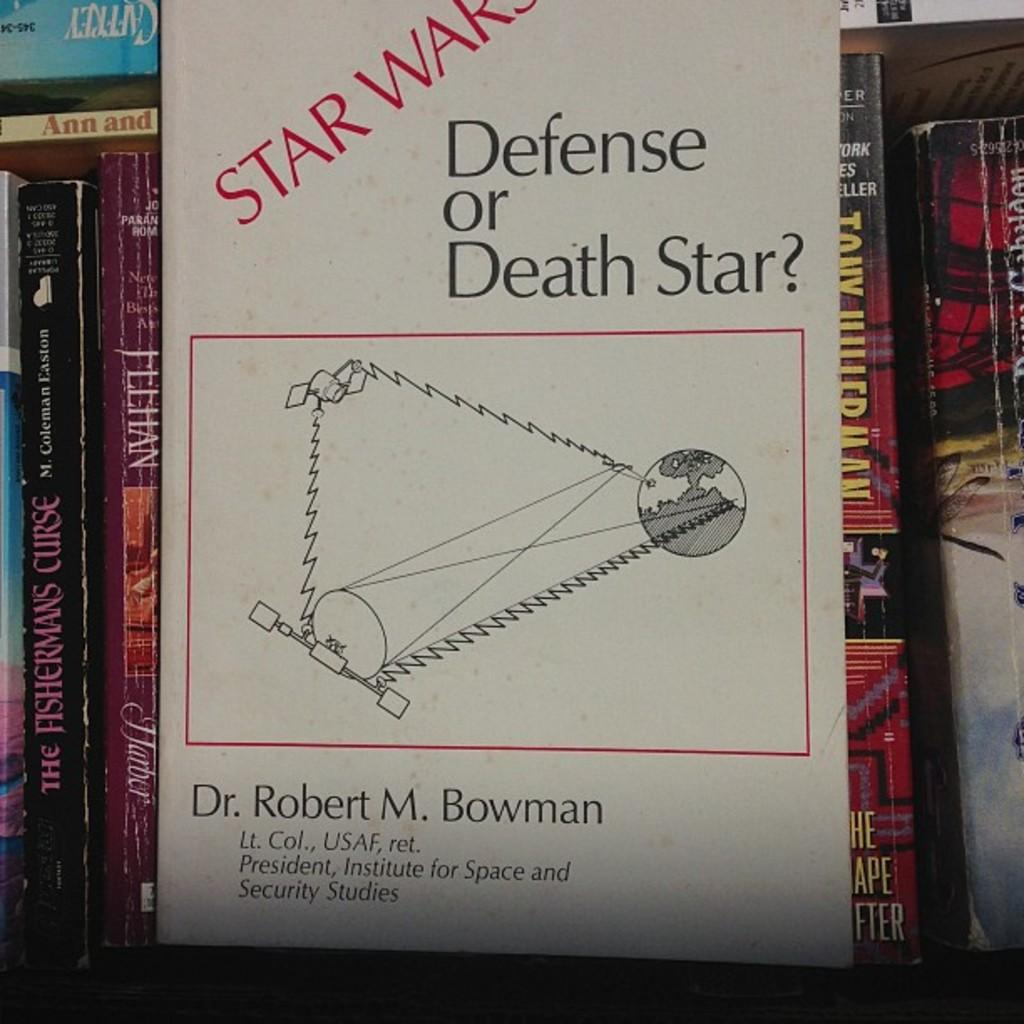<image>
Create a compact narrative representing the image presented. A book called, "Star Wars Defense of Death Star" by Dr. Robert M. Bowman is near several other books. 